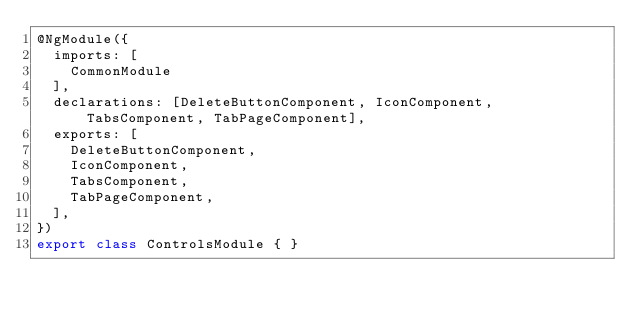Convert code to text. <code><loc_0><loc_0><loc_500><loc_500><_TypeScript_>@NgModule({
  imports: [
    CommonModule
  ],
  declarations: [DeleteButtonComponent, IconComponent, TabsComponent, TabPageComponent],
  exports: [
    DeleteButtonComponent,
    IconComponent,
    TabsComponent,
    TabPageComponent,
  ],
})
export class ControlsModule { }
</code> 